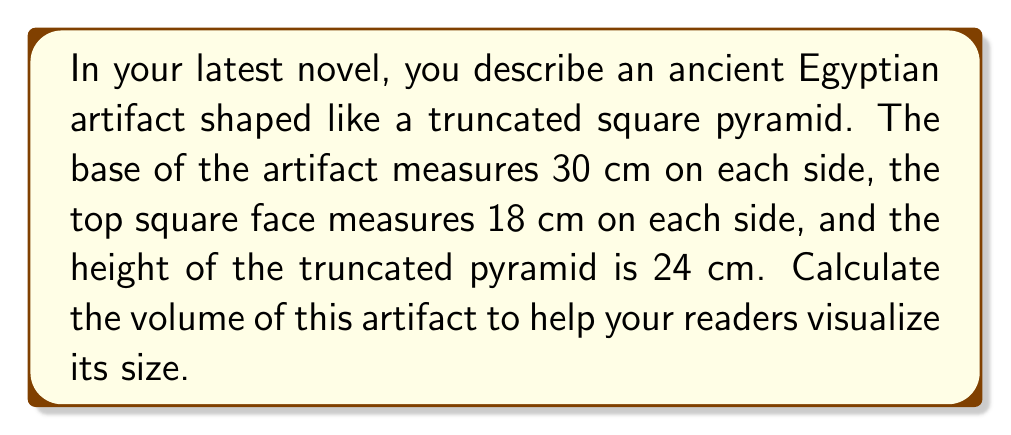What is the answer to this math problem? To calculate the volume of a truncated square pyramid, we'll use the formula:

$$V = \frac{1}{3}h(a^2 + ab + b^2)$$

Where:
$V$ = volume
$h$ = height of the truncated pyramid
$a$ = side length of the larger base
$b$ = side length of the smaller top face

Step 1: Identify the given values
$h = 24$ cm
$a = 30$ cm
$b = 18$ cm

Step 2: Substitute these values into the formula
$$V = \frac{1}{3} \times 24 \times (30^2 + 30 \times 18 + 18^2)$$

Step 3: Calculate the squares
$$V = \frac{1}{3} \times 24 \times (900 + 540 + 324)$$

Step 4: Sum the values inside the parentheses
$$V = \frac{1}{3} \times 24 \times 1764$$

Step 5: Multiply
$$V = 8 \times 1764 = 14,112$$

Therefore, the volume of the truncated pyramid is 14,112 cubic centimeters.
Answer: 14,112 cm³ 